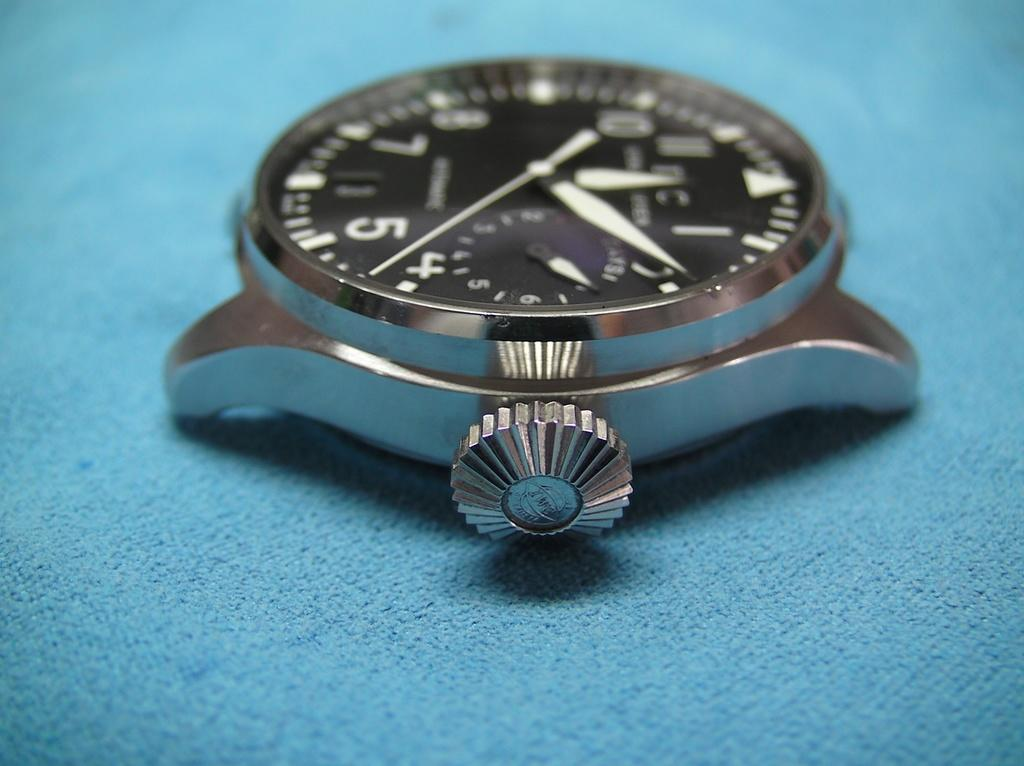<image>
Relay a brief, clear account of the picture shown. The number 5 is visible on a watch face that is sitting on a blue cloth. 